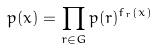Convert formula to latex. <formula><loc_0><loc_0><loc_500><loc_500>p ( x ) = \prod _ { r \in G } p ( r ) ^ { f _ { r } ( x ) }</formula> 